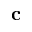Convert formula to latex. <formula><loc_0><loc_0><loc_500><loc_500>c</formula> 